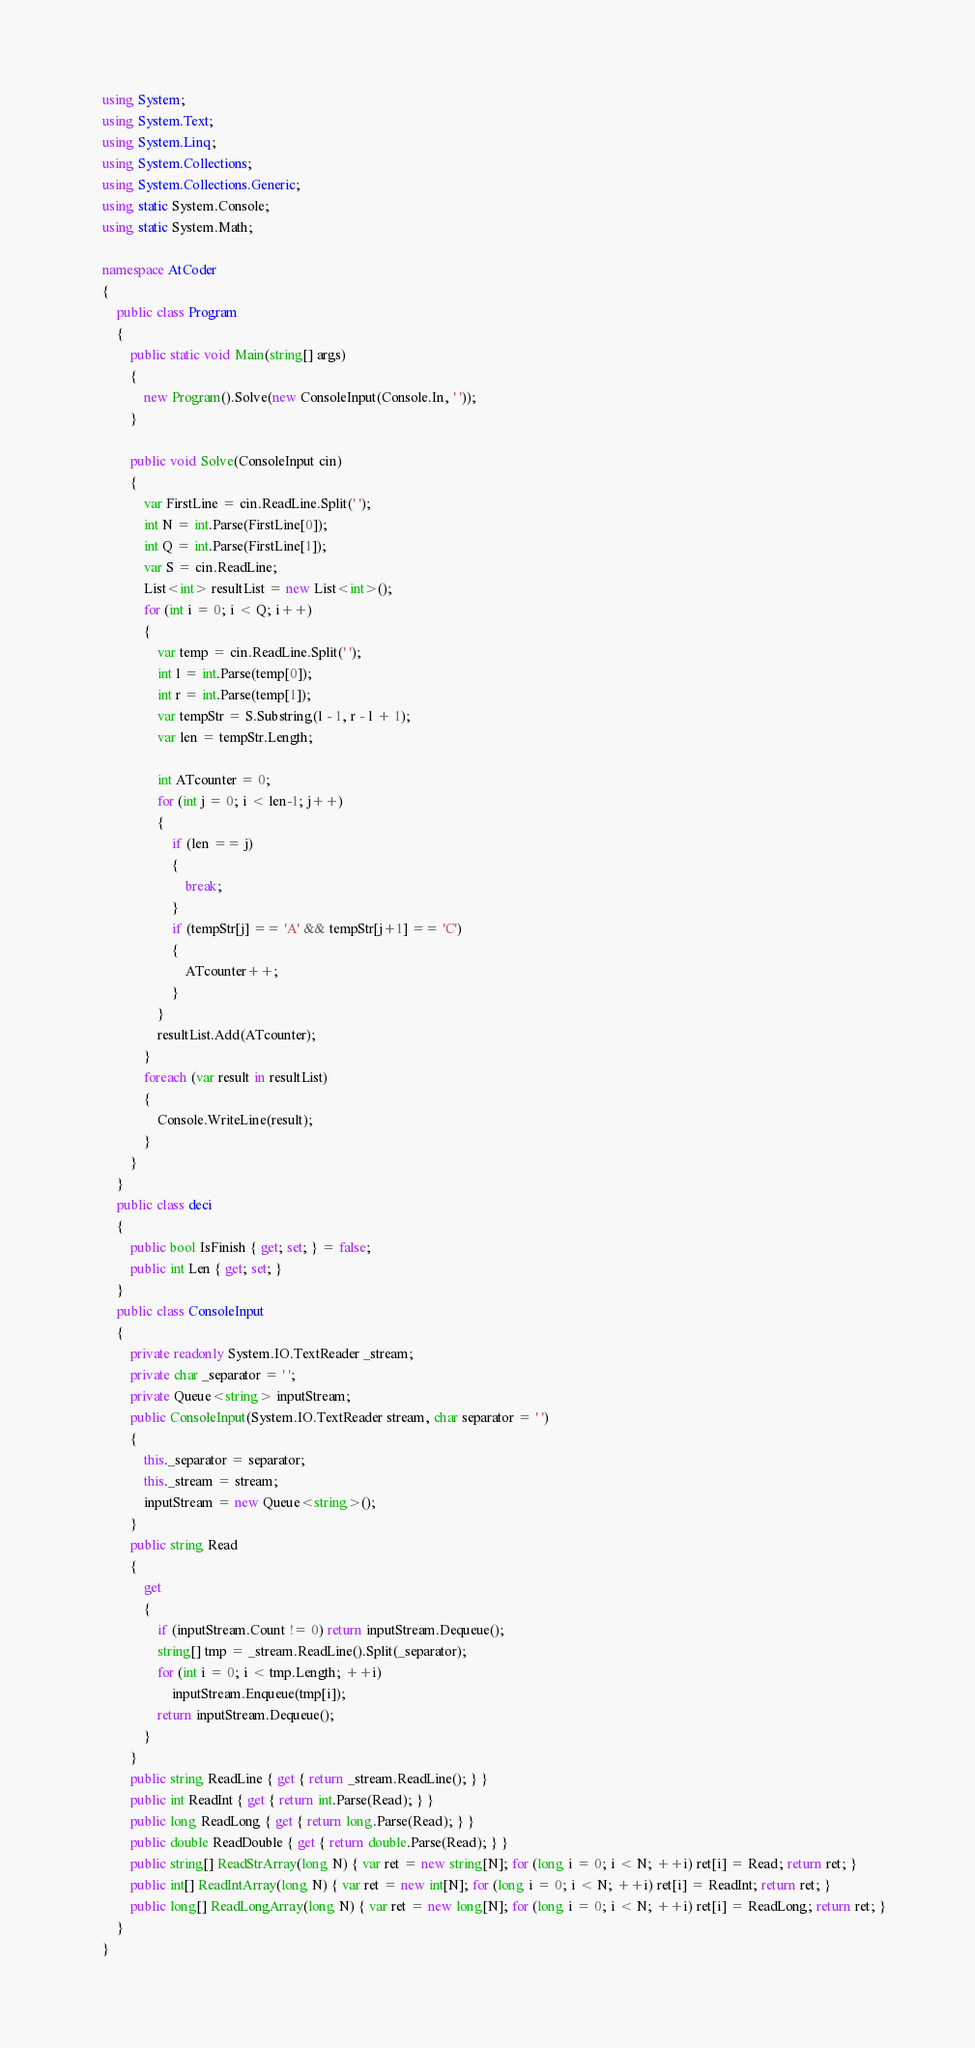Convert code to text. <code><loc_0><loc_0><loc_500><loc_500><_C#_>    using System;
    using System.Text;
    using System.Linq;
    using System.Collections;
    using System.Collections.Generic;
    using static System.Console;
    using static System.Math;

    namespace AtCoder
    {
        public class Program
        {
            public static void Main(string[] args)
            {
                new Program().Solve(new ConsoleInput(Console.In, ' '));
            }

            public void Solve(ConsoleInput cin)
            {
                var FirstLine = cin.ReadLine.Split(' ');
                int N = int.Parse(FirstLine[0]);
                int Q = int.Parse(FirstLine[1]);
                var S = cin.ReadLine;
                List<int> resultList = new List<int>();
                for (int i = 0; i < Q; i++)
                {
                    var temp = cin.ReadLine.Split(' ');
                    int l = int.Parse(temp[0]);
                    int r = int.Parse(temp[1]);
                    var tempStr = S.Substring(l - 1, r - l + 1);
                    var len = tempStr.Length;

                    int ATcounter = 0;
                    for (int j = 0; i < len-1; j++)
                    {
                        if (len == j)
                        {
                            break;
                        }
                        if (tempStr[j] == 'A' && tempStr[j+1] == 'C')
                        {
                            ATcounter++;
                        }
                    }
                    resultList.Add(ATcounter);
                }
                foreach (var result in resultList)
                {
                    Console.WriteLine(result);
                }
            }
        }
        public class deci
        {
            public bool IsFinish { get; set; } = false;
            public int Len { get; set; }
        }
        public class ConsoleInput
        {
            private readonly System.IO.TextReader _stream;
            private char _separator = ' ';
            private Queue<string> inputStream;
            public ConsoleInput(System.IO.TextReader stream, char separator = ' ')
            {
                this._separator = separator;
                this._stream = stream;
                inputStream = new Queue<string>();
            }
            public string Read
            {
                get
                {
                    if (inputStream.Count != 0) return inputStream.Dequeue();
                    string[] tmp = _stream.ReadLine().Split(_separator);
                    for (int i = 0; i < tmp.Length; ++i)
                        inputStream.Enqueue(tmp[i]);
                    return inputStream.Dequeue();
                }
            }
            public string ReadLine { get { return _stream.ReadLine(); } }
            public int ReadInt { get { return int.Parse(Read); } }
            public long ReadLong { get { return long.Parse(Read); } }
            public double ReadDouble { get { return double.Parse(Read); } }
            public string[] ReadStrArray(long N) { var ret = new string[N]; for (long i = 0; i < N; ++i) ret[i] = Read; return ret; }
            public int[] ReadIntArray(long N) { var ret = new int[N]; for (long i = 0; i < N; ++i) ret[i] = ReadInt; return ret; }
            public long[] ReadLongArray(long N) { var ret = new long[N]; for (long i = 0; i < N; ++i) ret[i] = ReadLong; return ret; }
        }
    }</code> 